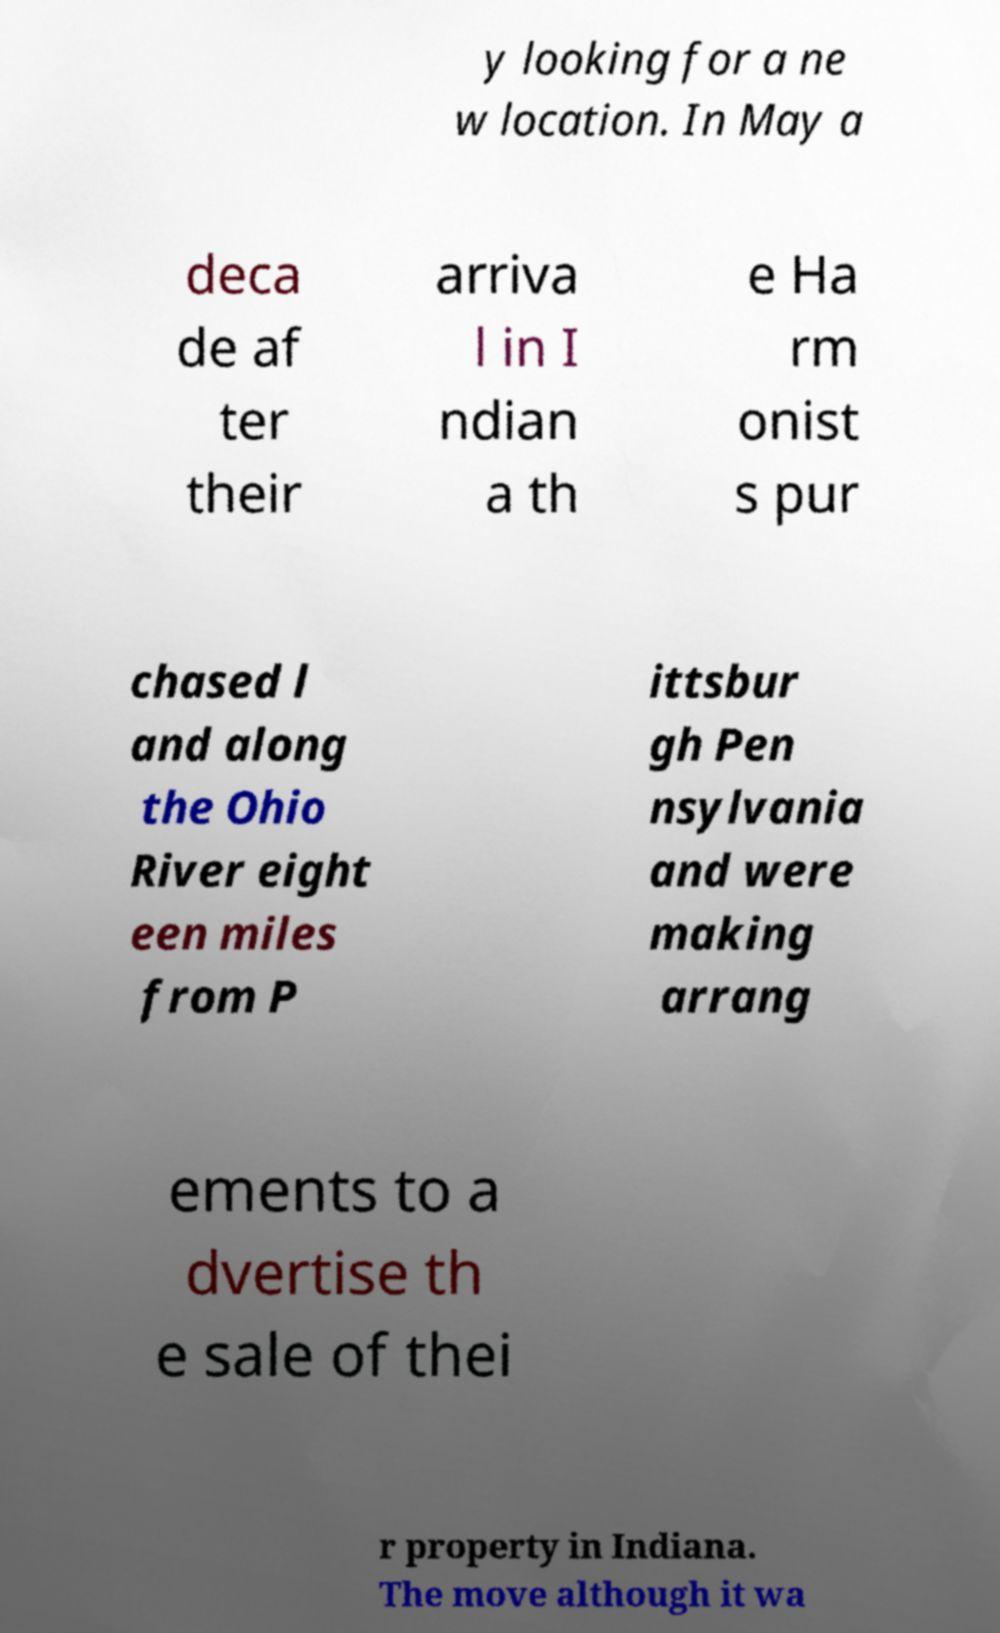I need the written content from this picture converted into text. Can you do that? y looking for a ne w location. In May a deca de af ter their arriva l in I ndian a th e Ha rm onist s pur chased l and along the Ohio River eight een miles from P ittsbur gh Pen nsylvania and were making arrang ements to a dvertise th e sale of thei r property in Indiana. The move although it wa 